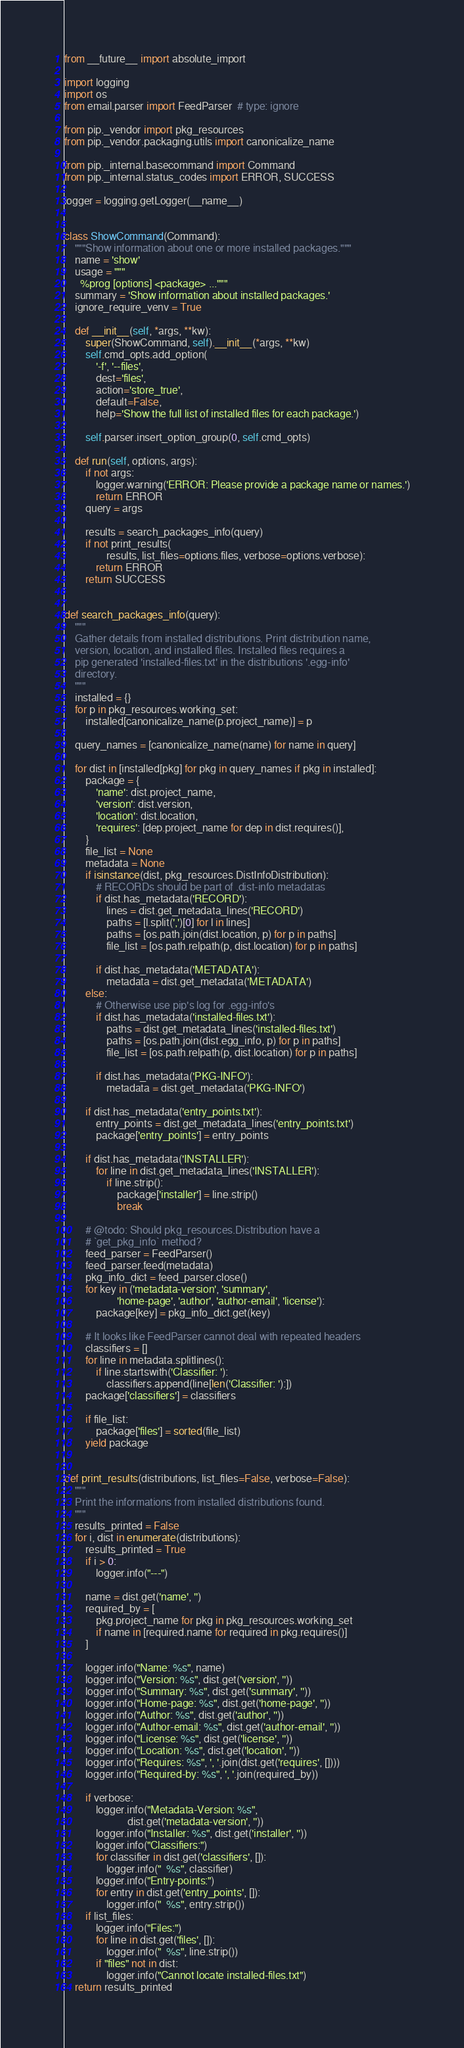Convert code to text. <code><loc_0><loc_0><loc_500><loc_500><_Python_>from __future__ import absolute_import

import logging
import os
from email.parser import FeedParser  # type: ignore

from pip._vendor import pkg_resources
from pip._vendor.packaging.utils import canonicalize_name

from pip._internal.basecommand import Command
from pip._internal.status_codes import ERROR, SUCCESS

logger = logging.getLogger(__name__)


class ShowCommand(Command):
    """Show information about one or more installed packages."""
    name = 'show'
    usage = """
      %prog [options] <package> ..."""
    summary = 'Show information about installed packages.'
    ignore_require_venv = True

    def __init__(self, *args, **kw):
        super(ShowCommand, self).__init__(*args, **kw)
        self.cmd_opts.add_option(
            '-f', '--files',
            dest='files',
            action='store_true',
            default=False,
            help='Show the full list of installed files for each package.')

        self.parser.insert_option_group(0, self.cmd_opts)

    def run(self, options, args):
        if not args:
            logger.warning('ERROR: Please provide a package name or names.')
            return ERROR
        query = args

        results = search_packages_info(query)
        if not print_results(
                results, list_files=options.files, verbose=options.verbose):
            return ERROR
        return SUCCESS


def search_packages_info(query):
    """
    Gather details from installed distributions. Print distribution name,
    version, location, and installed files. Installed files requires a
    pip generated 'installed-files.txt' in the distributions '.egg-info'
    directory.
    """
    installed = {}
    for p in pkg_resources.working_set:
        installed[canonicalize_name(p.project_name)] = p

    query_names = [canonicalize_name(name) for name in query]

    for dist in [installed[pkg] for pkg in query_names if pkg in installed]:
        package = {
            'name': dist.project_name,
            'version': dist.version,
            'location': dist.location,
            'requires': [dep.project_name for dep in dist.requires()],
        }
        file_list = None
        metadata = None
        if isinstance(dist, pkg_resources.DistInfoDistribution):
            # RECORDs should be part of .dist-info metadatas
            if dist.has_metadata('RECORD'):
                lines = dist.get_metadata_lines('RECORD')
                paths = [l.split(',')[0] for l in lines]
                paths = [os.path.join(dist.location, p) for p in paths]
                file_list = [os.path.relpath(p, dist.location) for p in paths]

            if dist.has_metadata('METADATA'):
                metadata = dist.get_metadata('METADATA')
        else:
            # Otherwise use pip's log for .egg-info's
            if dist.has_metadata('installed-files.txt'):
                paths = dist.get_metadata_lines('installed-files.txt')
                paths = [os.path.join(dist.egg_info, p) for p in paths]
                file_list = [os.path.relpath(p, dist.location) for p in paths]

            if dist.has_metadata('PKG-INFO'):
                metadata = dist.get_metadata('PKG-INFO')

        if dist.has_metadata('entry_points.txt'):
            entry_points = dist.get_metadata_lines('entry_points.txt')
            package['entry_points'] = entry_points

        if dist.has_metadata('INSTALLER'):
            for line in dist.get_metadata_lines('INSTALLER'):
                if line.strip():
                    package['installer'] = line.strip()
                    break

        # @todo: Should pkg_resources.Distribution have a
        # `get_pkg_info` method?
        feed_parser = FeedParser()
        feed_parser.feed(metadata)
        pkg_info_dict = feed_parser.close()
        for key in ('metadata-version', 'summary',
                    'home-page', 'author', 'author-email', 'license'):
            package[key] = pkg_info_dict.get(key)

        # It looks like FeedParser cannot deal with repeated headers
        classifiers = []
        for line in metadata.splitlines():
            if line.startswith('Classifier: '):
                classifiers.append(line[len('Classifier: '):])
        package['classifiers'] = classifiers

        if file_list:
            package['files'] = sorted(file_list)
        yield package


def print_results(distributions, list_files=False, verbose=False):
    """
    Print the informations from installed distributions found.
    """
    results_printed = False
    for i, dist in enumerate(distributions):
        results_printed = True
        if i > 0:
            logger.info("---")

        name = dist.get('name', '')
        required_by = [
            pkg.project_name for pkg in pkg_resources.working_set
            if name in [required.name for required in pkg.requires()]
        ]

        logger.info("Name: %s", name)
        logger.info("Version: %s", dist.get('version', ''))
        logger.info("Summary: %s", dist.get('summary', ''))
        logger.info("Home-page: %s", dist.get('home-page', ''))
        logger.info("Author: %s", dist.get('author', ''))
        logger.info("Author-email: %s", dist.get('author-email', ''))
        logger.info("License: %s", dist.get('license', ''))
        logger.info("Location: %s", dist.get('location', ''))
        logger.info("Requires: %s", ', '.join(dist.get('requires', [])))
        logger.info("Required-by: %s", ', '.join(required_by))

        if verbose:
            logger.info("Metadata-Version: %s",
                        dist.get('metadata-version', ''))
            logger.info("Installer: %s", dist.get('installer', ''))
            logger.info("Classifiers:")
            for classifier in dist.get('classifiers', []):
                logger.info("  %s", classifier)
            logger.info("Entry-points:")
            for entry in dist.get('entry_points', []):
                logger.info("  %s", entry.strip())
        if list_files:
            logger.info("Files:")
            for line in dist.get('files', []):
                logger.info("  %s", line.strip())
            if "files" not in dist:
                logger.info("Cannot locate installed-files.txt")
    return results_printed
</code> 